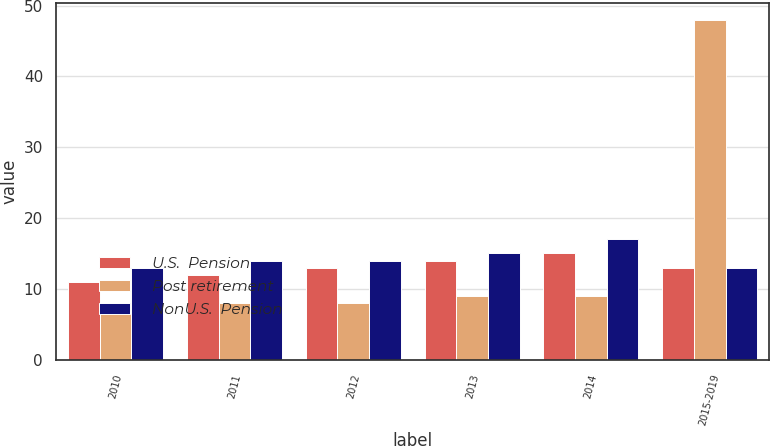Convert chart to OTSL. <chart><loc_0><loc_0><loc_500><loc_500><stacked_bar_chart><ecel><fcel>2010<fcel>2011<fcel>2012<fcel>2013<fcel>2014<fcel>2015-2019<nl><fcel>U.S.  Pension<fcel>11<fcel>12<fcel>13<fcel>14<fcel>15<fcel>13<nl><fcel>Post retirement<fcel>8<fcel>8<fcel>8<fcel>9<fcel>9<fcel>48<nl><fcel>NonU.S.  Pension<fcel>13<fcel>14<fcel>14<fcel>15<fcel>17<fcel>13<nl></chart> 